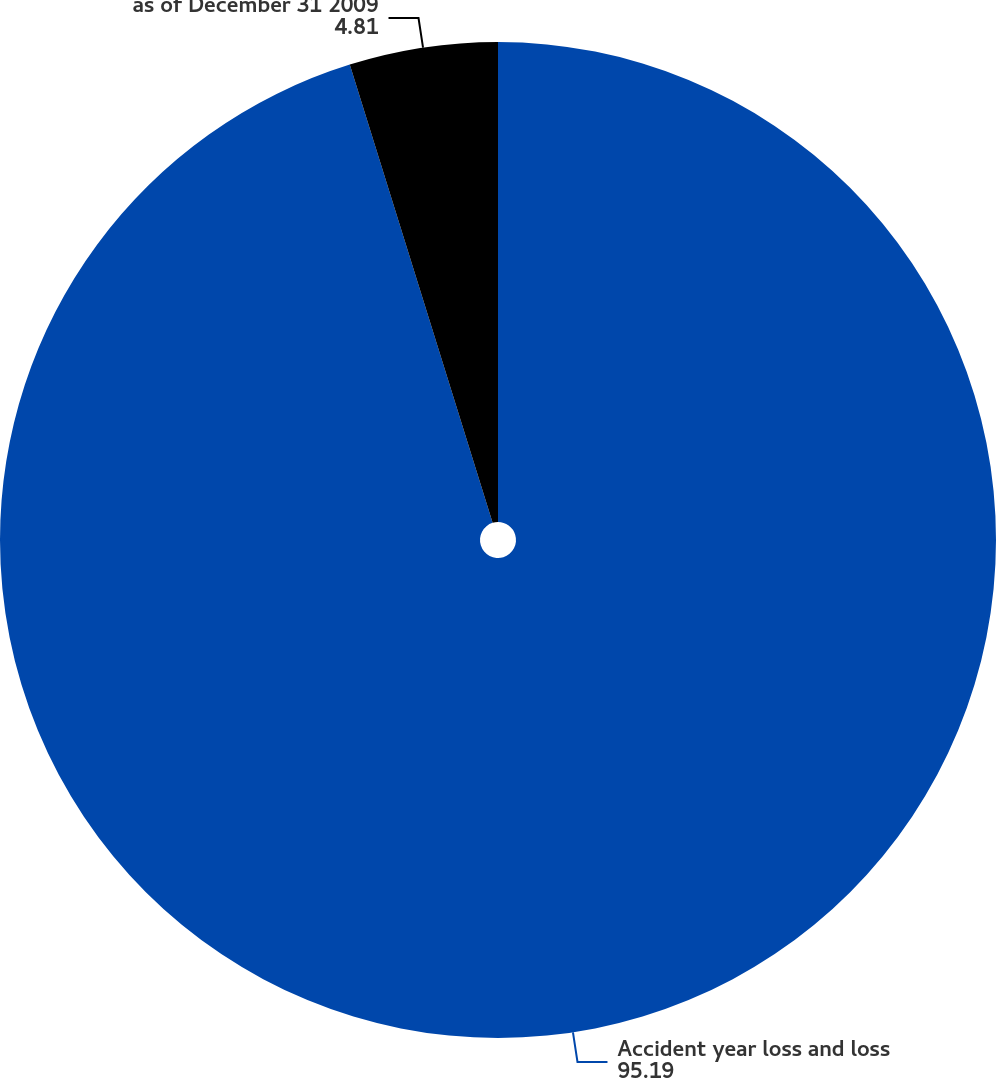<chart> <loc_0><loc_0><loc_500><loc_500><pie_chart><fcel>Accident year loss and loss<fcel>as of December 31 2009<nl><fcel>95.19%<fcel>4.81%<nl></chart> 